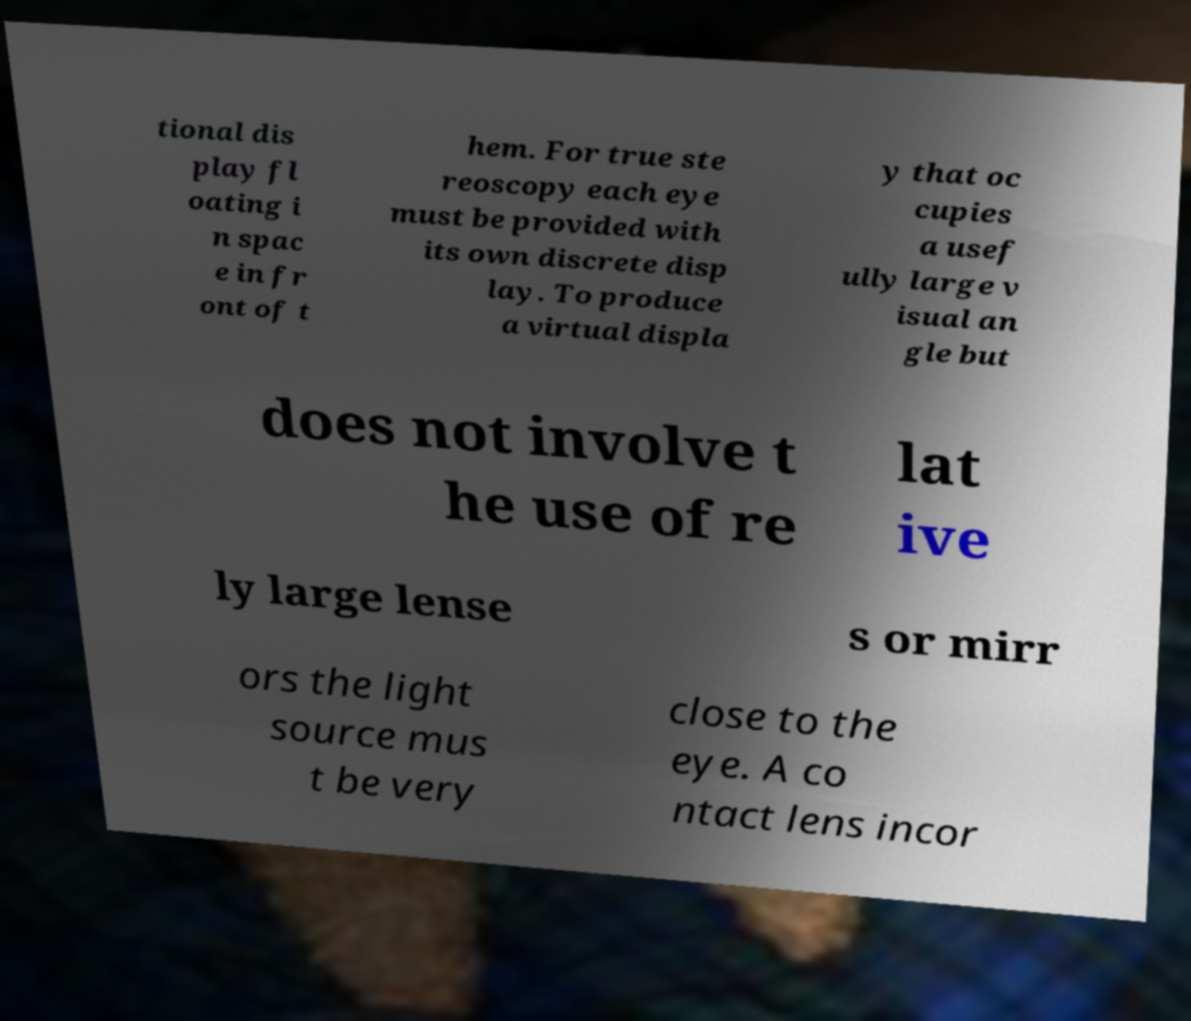There's text embedded in this image that I need extracted. Can you transcribe it verbatim? tional dis play fl oating i n spac e in fr ont of t hem. For true ste reoscopy each eye must be provided with its own discrete disp lay. To produce a virtual displa y that oc cupies a usef ully large v isual an gle but does not involve t he use of re lat ive ly large lense s or mirr ors the light source mus t be very close to the eye. A co ntact lens incor 